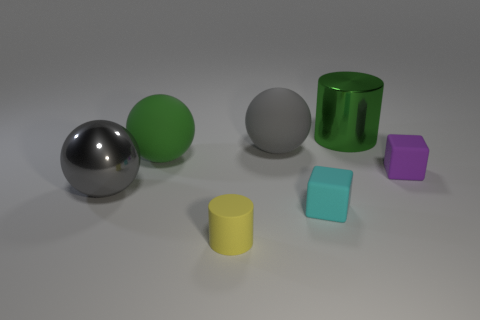Do the small purple object and the small cylinder have the same material?
Offer a terse response. Yes. There is a cylinder on the left side of the big sphere right of the yellow object; what number of metal things are left of it?
Provide a short and direct response. 1. The tiny cube on the left side of the tiny purple object is what color?
Keep it short and to the point. Cyan. The tiny thing that is on the right side of the cylinder that is behind the purple block is what shape?
Provide a short and direct response. Cube. Does the metallic cylinder have the same color as the metal sphere?
Ensure brevity in your answer.  No. What number of spheres are small yellow rubber objects or big gray things?
Ensure brevity in your answer.  2. There is a thing that is to the right of the large gray rubber thing and to the left of the big green shiny object; what material is it made of?
Your response must be concise. Rubber. There is a metal cylinder; what number of tiny cubes are behind it?
Keep it short and to the point. 0. Does the cylinder that is left of the cyan rubber cube have the same material as the cylinder that is to the right of the tiny cyan matte cube?
Your answer should be very brief. No. What number of objects are either tiny things in front of the green matte object or big cyan things?
Give a very brief answer. 3. 